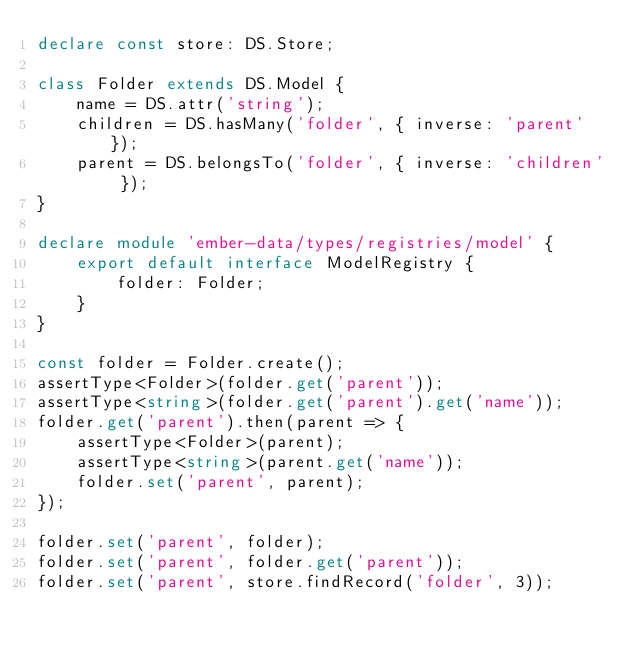Convert code to text. <code><loc_0><loc_0><loc_500><loc_500><_TypeScript_>declare const store: DS.Store;

class Folder extends DS.Model {
    name = DS.attr('string');
    children = DS.hasMany('folder', { inverse: 'parent' });
    parent = DS.belongsTo('folder', { inverse: 'children' });
}

declare module 'ember-data/types/registries/model' {
    export default interface ModelRegistry {
        folder: Folder;
    }
}

const folder = Folder.create();
assertType<Folder>(folder.get('parent'));
assertType<string>(folder.get('parent').get('name'));
folder.get('parent').then(parent => {
    assertType<Folder>(parent);
    assertType<string>(parent.get('name'));
    folder.set('parent', parent);
});

folder.set('parent', folder);
folder.set('parent', folder.get('parent'));
folder.set('parent', store.findRecord('folder', 3));
</code> 